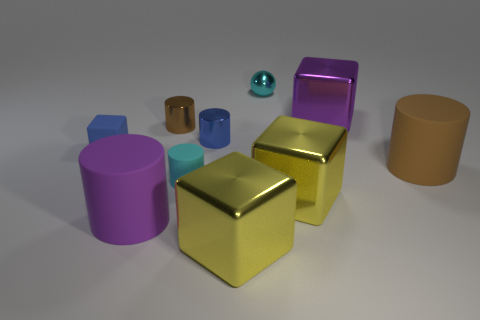Subtract all cyan cylinders. How many cylinders are left? 4 Subtract all cyan cylinders. How many cylinders are left? 4 Subtract all yellow balls. Subtract all yellow cylinders. How many balls are left? 1 Subtract all spheres. How many objects are left? 9 Add 2 cyan metal things. How many cyan metal things exist? 3 Subtract 1 purple cylinders. How many objects are left? 9 Subtract all yellow things. Subtract all small brown things. How many objects are left? 7 Add 8 tiny brown objects. How many tiny brown objects are left? 9 